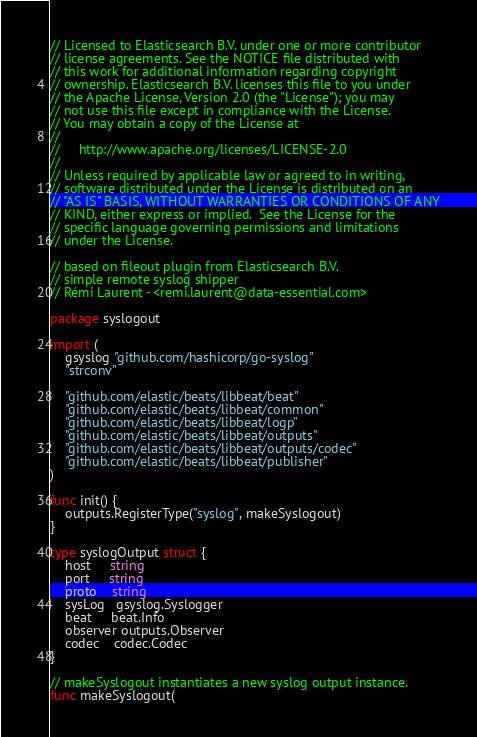Convert code to text. <code><loc_0><loc_0><loc_500><loc_500><_Go_>// Licensed to Elasticsearch B.V. under one or more contributor
// license agreements. See the NOTICE file distributed with
// this work for additional information regarding copyright
// ownership. Elasticsearch B.V. licenses this file to you under
// the Apache License, Version 2.0 (the "License"); you may
// not use this file except in compliance with the License.
// You may obtain a copy of the License at
//
//     http://www.apache.org/licenses/LICENSE-2.0
//
// Unless required by applicable law or agreed to in writing,
// software distributed under the License is distributed on an
// "AS IS" BASIS, WITHOUT WARRANTIES OR CONDITIONS OF ANY
// KIND, either express or implied.  See the License for the
// specific language governing permissions and limitations
// under the License.

// based on fileout plugin from Elasticsearch B.V.
// simple remote syslog shipper
// Rémi Laurent - <remi.laurent@data-essential.com>

package syslogout

import (
	gsyslog "github.com/hashicorp/go-syslog"
	"strconv"

	"github.com/elastic/beats/libbeat/beat"
	"github.com/elastic/beats/libbeat/common"
	"github.com/elastic/beats/libbeat/logp"
	"github.com/elastic/beats/libbeat/outputs"
	"github.com/elastic/beats/libbeat/outputs/codec"
	"github.com/elastic/beats/libbeat/publisher"
)

func init() {
	outputs.RegisterType("syslog", makeSyslogout)
}

type syslogOutput struct {
	host     string
	port     string
	proto    string
	sysLog   gsyslog.Syslogger
	beat     beat.Info
	observer outputs.Observer
	codec    codec.Codec
}

// makeSyslogout instantiates a new syslog output instance.
func makeSyslogout(</code> 